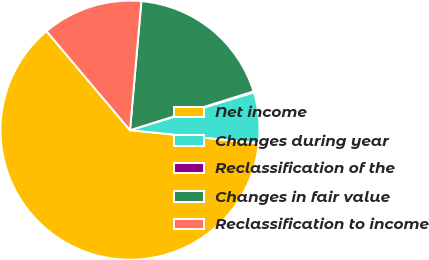Convert chart to OTSL. <chart><loc_0><loc_0><loc_500><loc_500><pie_chart><fcel>Net income<fcel>Changes during year<fcel>Reclassification of the<fcel>Changes in fair value<fcel>Reclassification to income<nl><fcel>62.24%<fcel>6.33%<fcel>0.12%<fcel>18.76%<fcel>12.55%<nl></chart> 